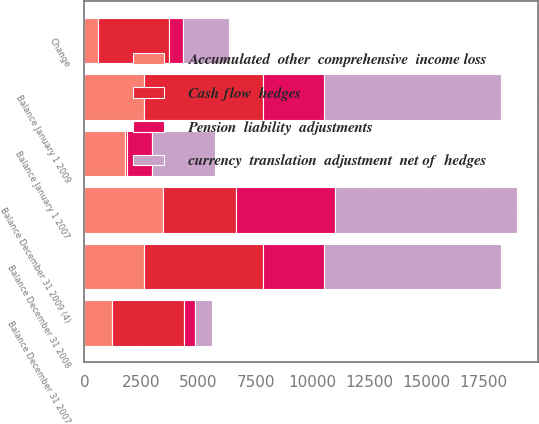<chart> <loc_0><loc_0><loc_500><loc_500><stacked_bar_chart><ecel><fcel>Balance January 1 2007<fcel>Change<fcel>Balance December 31 2007<fcel>Balance December 31 2008<fcel>Balance January 1 2009<fcel>Balance December 31 2009 (4)<nl><fcel>Pension  liability  adjustments<fcel>1092<fcel>621<fcel>471<fcel>2705.5<fcel>2705.5<fcel>4347<nl><fcel>currency  translation  adjustment  net of  hedges<fcel>2796<fcel>2024<fcel>772<fcel>7744<fcel>7744<fcel>7947<nl><fcel>Cash flow  hedges<fcel>61<fcel>3102<fcel>3163<fcel>5189<fcel>5189<fcel>3182<nl><fcel>Accumulated  other  comprehensive  income loss<fcel>1786<fcel>590<fcel>1196<fcel>2615<fcel>2615<fcel>3461<nl></chart> 